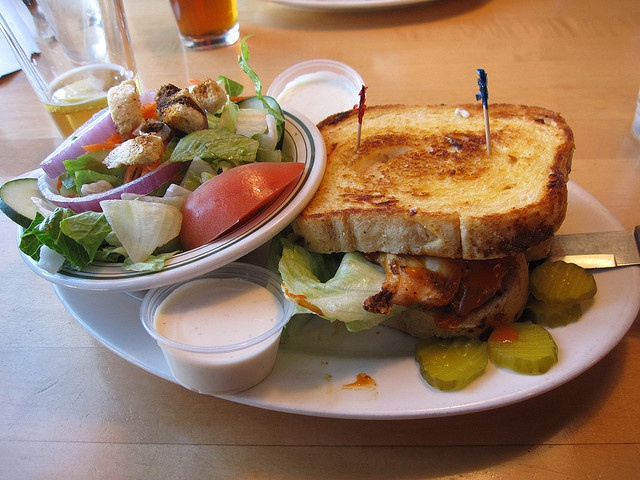Describe the objects in this image and their specific colors. I can see dining table in tan, maroon, darkgray, brown, and black tones, sandwich in lightblue, black, brown, maroon, and tan tones, bowl in lightblue, gray, lightgray, tan, and darkgray tones, cup in lightblue, lightgray, and darkgray tones, and cup in lightblue, brown, darkgray, and white tones in this image. 